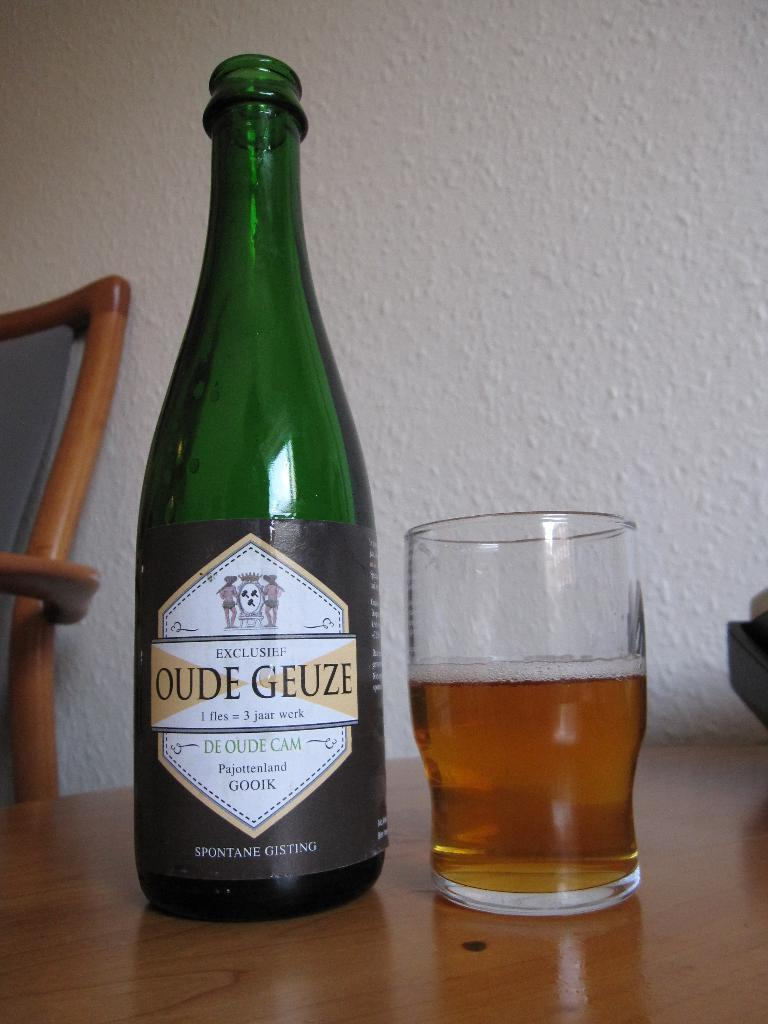What type of background is visible in the image? There is a white wall in the image. What type of furniture is present in the image? There is a chair in the image. What type of object can be seen on the table in the image? There is a glass on the table in the image. What other object is visible in the image? There is a bottle in the image. How many bikes are parked next to the white wall in the image? There are no bikes present in the image; it only features a white wall, a chair, a bottle, and a glass on the table. What type of stew is being served in the glass on the table? There is no stew present in the image; the glass on the table is empty. 